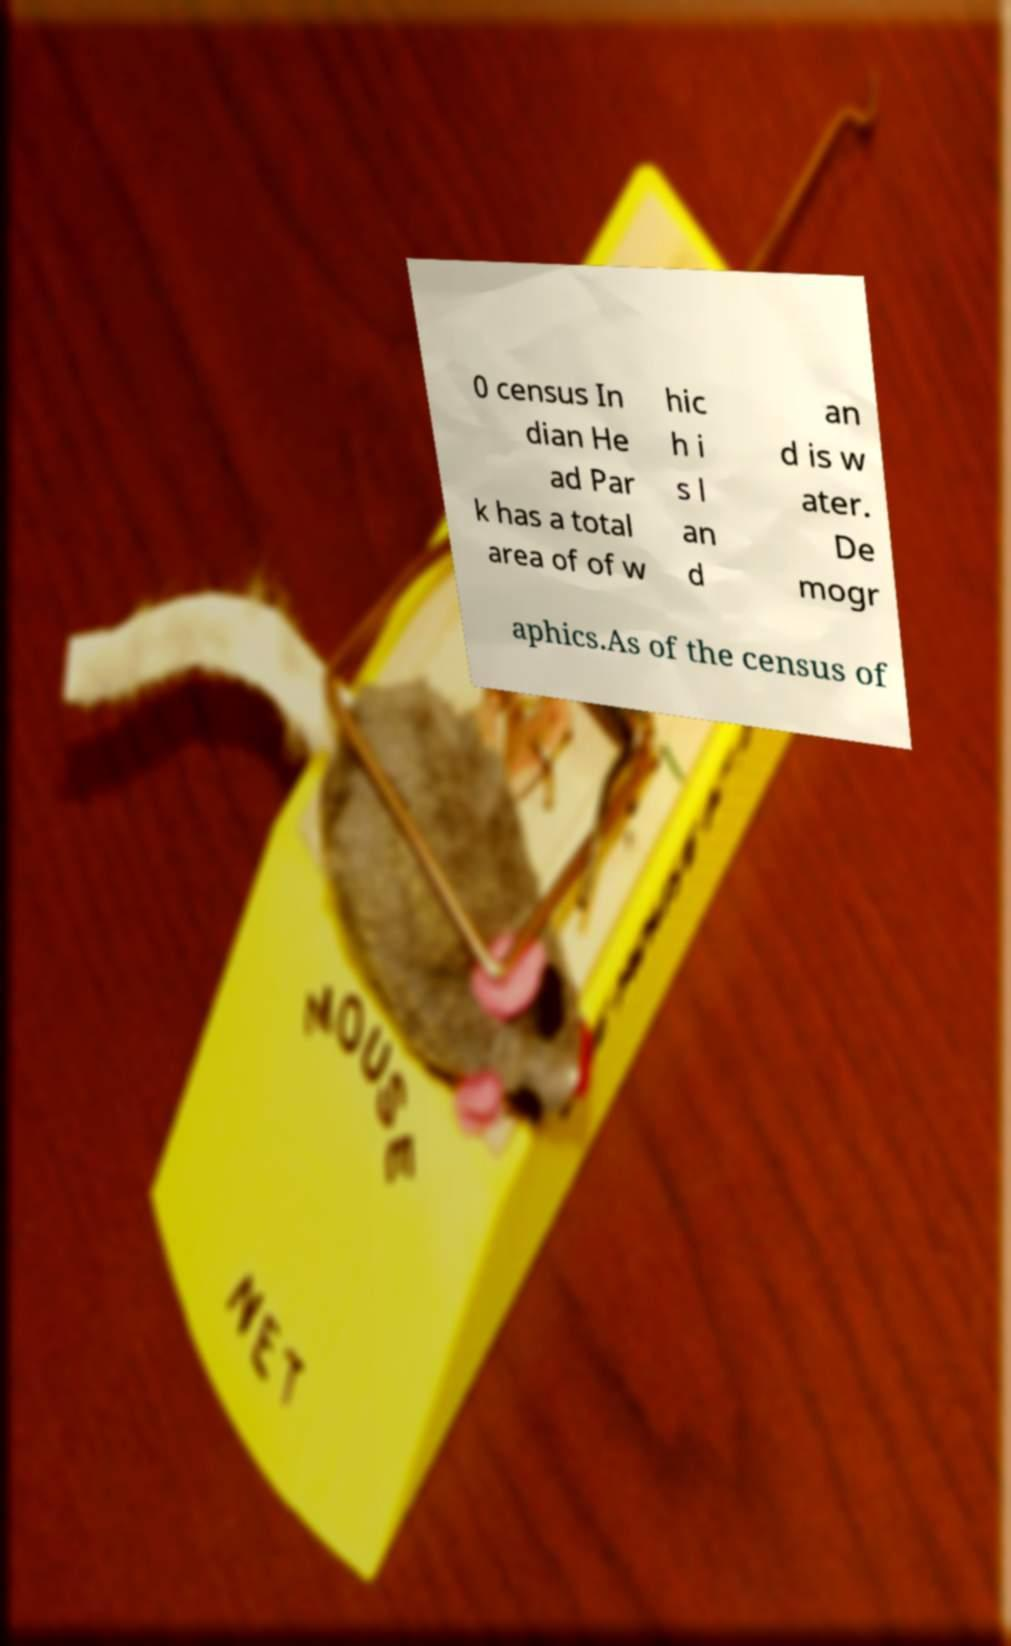Can you read and provide the text displayed in the image?This photo seems to have some interesting text. Can you extract and type it out for me? 0 census In dian He ad Par k has a total area of of w hic h i s l an d an d is w ater. De mogr aphics.As of the census of 